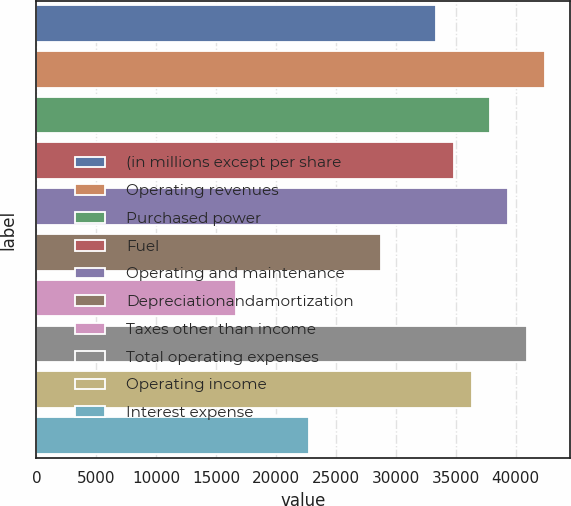Convert chart. <chart><loc_0><loc_0><loc_500><loc_500><bar_chart><fcel>(in millions except per share<fcel>Operating revenues<fcel>Purchased power<fcel>Fuel<fcel>Operating and maintenance<fcel>Depreciationandamortization<fcel>Taxes other than income<fcel>Total operating expenses<fcel>Operating income<fcel>Interest expense<nl><fcel>33325.3<fcel>42414<fcel>37869.7<fcel>34840.1<fcel>39384.4<fcel>28781<fcel>16662.8<fcel>40899.2<fcel>36354.9<fcel>22721.9<nl></chart> 